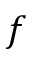Convert formula to latex. <formula><loc_0><loc_0><loc_500><loc_500>f</formula> 